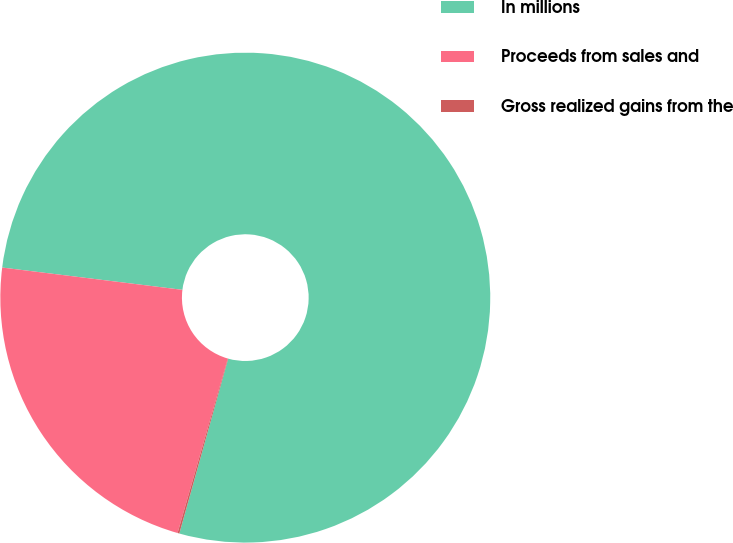<chart> <loc_0><loc_0><loc_500><loc_500><pie_chart><fcel>In millions<fcel>Proceeds from sales and<fcel>Gross realized gains from the<nl><fcel>77.38%<fcel>22.5%<fcel>0.12%<nl></chart> 